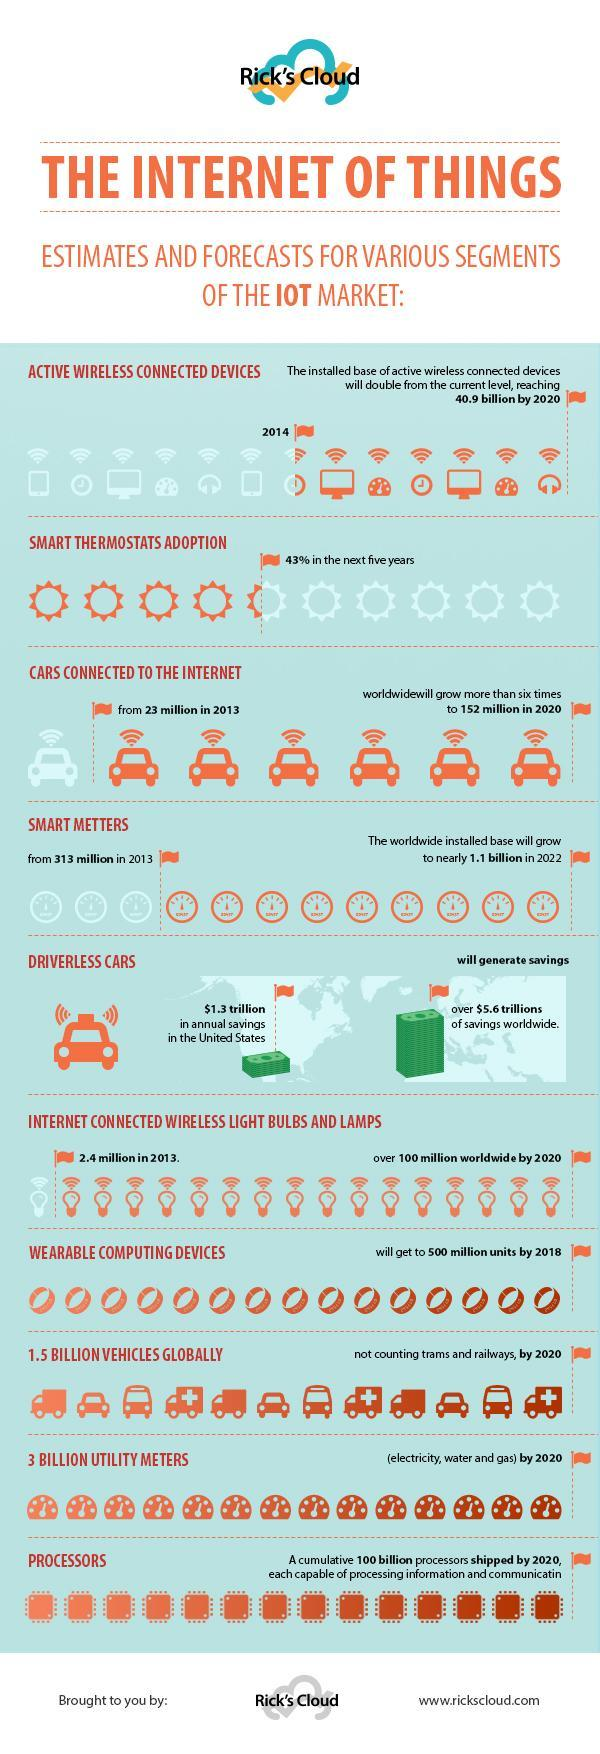What is projected increase in cars with internet from 2013 to 2020?
Answer the question with a short phrase. 129 million How many segments of the IOT market are listed in the document ? 10 Which is the projected increase in interconnected wireless lights and bulbs and lamps by 2020 from 2013? 97.7 million What is the projected increase in Smart meter from 2013 to 2022? 1,09,68,70,000 billion 